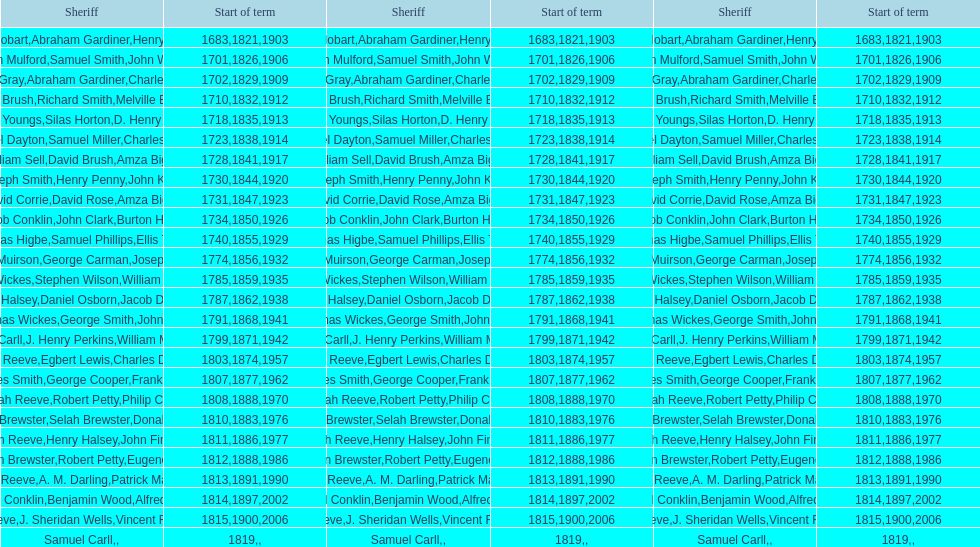When was benjamin brewster's second term of service? 1812. 